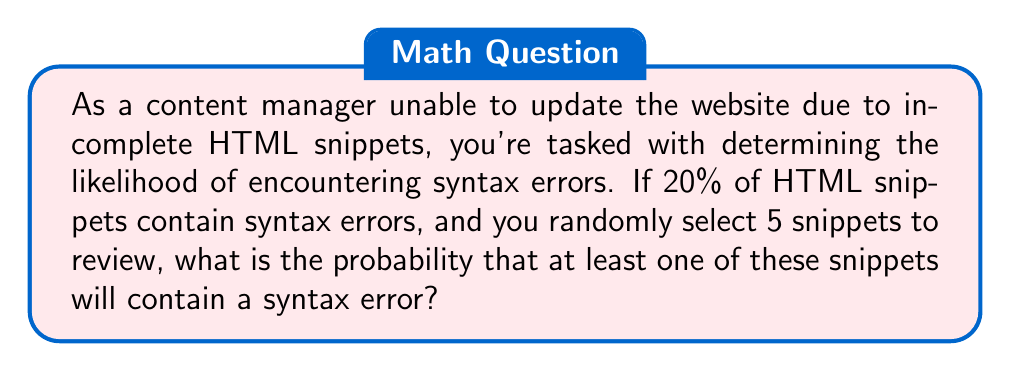Can you answer this question? Let's approach this step-by-step:

1) First, let's define our events:
   - Let $E$ be the event of encountering at least one syntax error in 5 snippets.
   - The probability of a single snippet having a syntax error is 20% or 0.2.

2) It's often easier to calculate the probability of the complement event:
   - The complement of $E$ is the event where none of the 5 snippets have a syntax error.

3) For a single snippet, the probability of not having a syntax error is:
   $1 - 0.2 = 0.8$ or 80%

4) For all 5 snippets to be error-free, each snippet must not have an error. The probability of this is:
   $0.8^5 = 0.32768$

5) Therefore, the probability of at least one snippet having an error is:
   $P(E) = 1 - P(\text{no errors}) = 1 - 0.32768 = 0.67232$

6) We can also calculate this using the binomial probability formula:
   $$P(X \geq 1) = 1 - P(X = 0) = 1 - \binom{5}{0}(0.2)^0(0.8)^5 = 1 - 0.32768 = 0.67232$$

   Where $X$ is the number of snippets with syntax errors.

This means there's approximately a 67.23% chance of encountering at least one syntax error in 5 randomly selected HTML snippets.
Answer: The probability of encountering at least one syntax error in 5 randomly selected HTML snippets is approximately 0.67232 or 67.23%. 